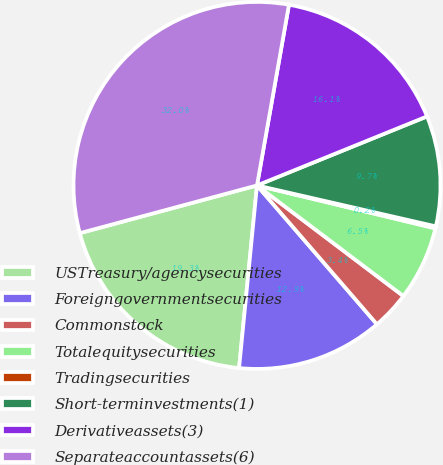<chart> <loc_0><loc_0><loc_500><loc_500><pie_chart><fcel>USTreasury/agencysecurities<fcel>Foreigngovernmentsecurities<fcel>Commonstock<fcel>Totalequitysecurities<fcel>Tradingsecurities<fcel>Short-terminvestments(1)<fcel>Derivativeassets(3)<fcel>Separateaccountassets(6)<nl><fcel>19.26%<fcel>12.9%<fcel>3.36%<fcel>6.54%<fcel>0.18%<fcel>9.72%<fcel>16.08%<fcel>31.98%<nl></chart> 